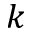<formula> <loc_0><loc_0><loc_500><loc_500>k</formula> 